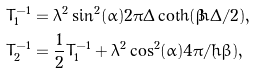Convert formula to latex. <formula><loc_0><loc_0><loc_500><loc_500>T _ { 1 } ^ { - 1 } & = \lambda ^ { 2 } \sin ^ { 2 } ( \alpha ) 2 \pi \Delta \coth ( \beta \hbar { \Delta } / 2 ) , \\ T _ { 2 } ^ { - 1 } & = \frac { 1 } { 2 } T _ { 1 } ^ { - 1 } + \lambda ^ { 2 } \cos ^ { 2 } ( \alpha ) 4 \pi / ( \hbar { \beta } ) ,</formula> 